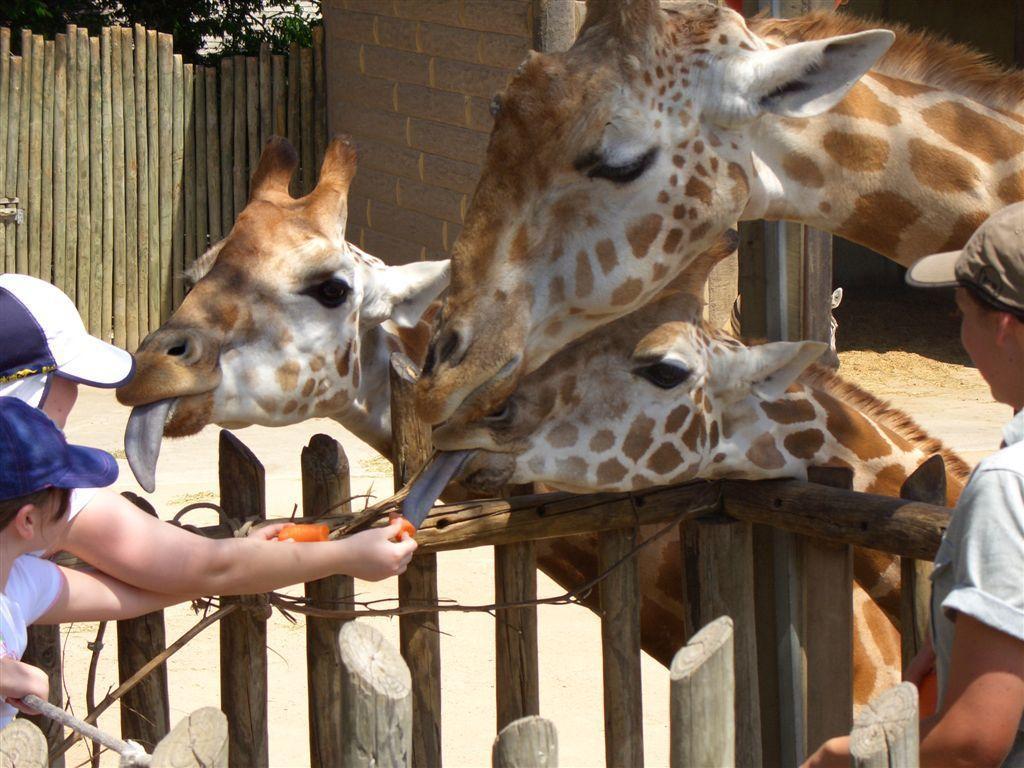Can you describe this image briefly? In this picture we can see three giraffes. We can see a person holding objects in the hands. We can see one of the giraffes licking an orange item. There are a few people visible on the right and left side of the image. We can see a few wooden objects, a wooden fence, wall and a few plants in the background. 